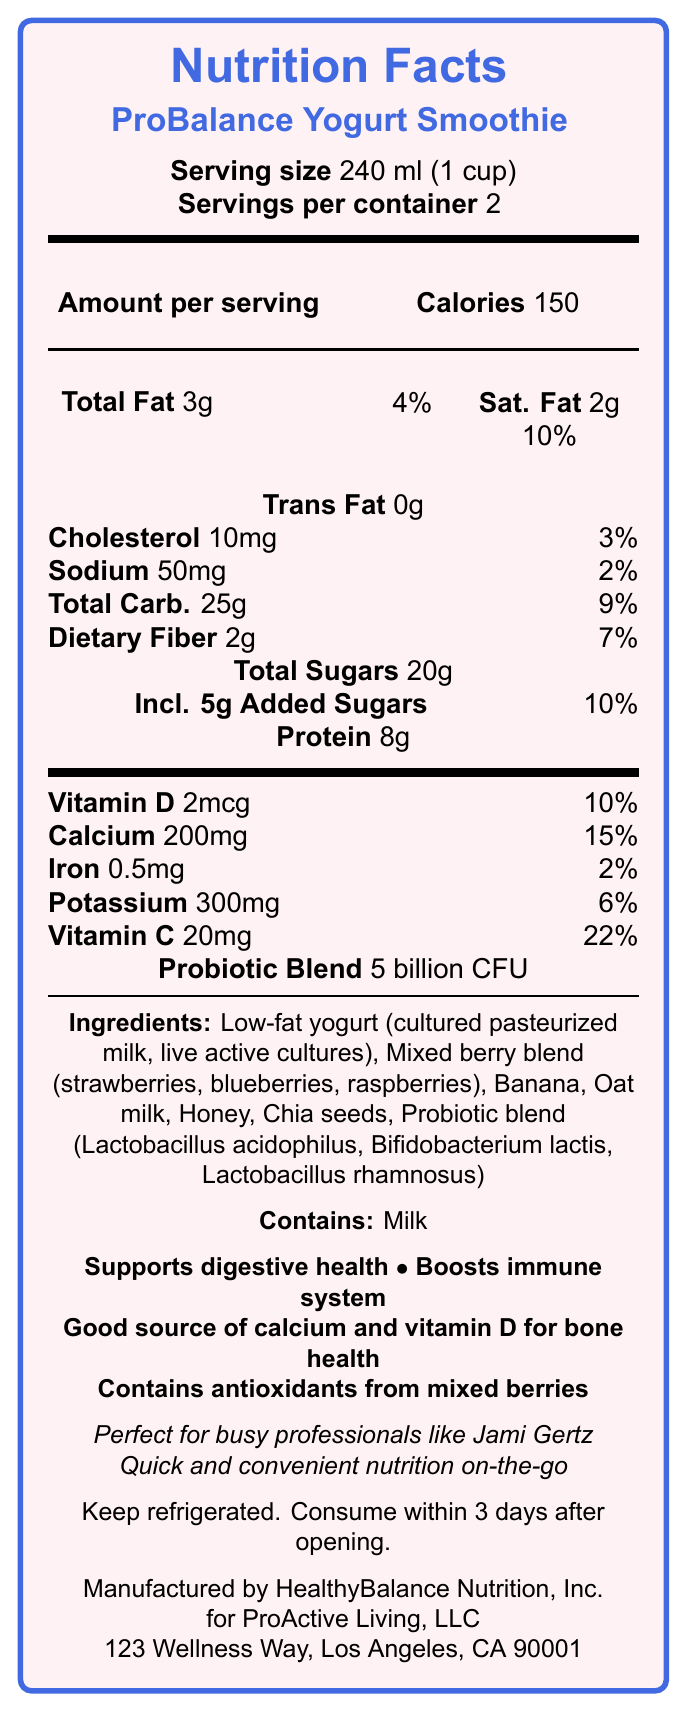How many calories are there per serving of the ProBalance Yogurt Smoothie? The document states that the calories per serving are 150.
Answer: 150 How many servings are in one container of the ProBalance Yogurt Smoothie? The document lists "Servings per container" as 2.
Answer: 2 What is the amount of total fat in one serving of the ProBalance Yogurt Smoothie? The document states that the total fat per serving is 3g.
Answer: 3g How much protein does one serving of the ProBalance Yogurt Smoothie contain? The document states that there are 8g of protein per serving.
Answer: 8g What are the ingredients listed in the ProBalance Yogurt Smoothie? The ingredients listed in the document are: Low-fat yogurt (cultured pasteurized milk, live active cultures), Mixed berry blend (strawberries, blueberries, raspberries), Banana, Oat milk, Honey, Chia seeds, Probiotic blend (Lactobacillus acidophilus, Bifidobacterium lactis, Lactobacillus rhamnosus).
Answer: Low-fat yogurt, Mixed berry blend, Banana, Oat milk, Honey, Chia seeds, Probiotic blend What is the daily value percentage of calcium in one serving of the ProBalance Yogurt Smoothie? The document indicates that the daily value percentage of calcium per serving is 15%.
Answer: 15% Which of the following health claims is associated with the ProBalance Yogurt Smoothie? A. Reduces cholesterol B. Supports digestive health C. Increases muscle mass The document states one of the health claims of the ProBalance Yogurt Smoothie is to "Supports digestive health".
Answer: B. Supports digestive health How much added sugar is in one serving of the ProBalance Yogurt Smoothie? A. 2g B. 5g C. 10g D. 15g The document states that there are 5g of "Added Sugars" per serving.
Answer: B. 5g Does the ProBalance Yogurt Smoothie contain any trans fat? The document states "Trans Fat 0g", which means there is no trans fat in the smoothie.
Answer: No Summarize the key points of the ProBalance Yogurt Smoothie nutrition facts label. This summary captures the main nutritional content, health benefits, and convenience of the ProBalance Yogurt Smoothie as presented in the document.
Answer: The ProBalance Yogurt Smoothie is a nutritious beverage containing 150 calories per serving, with 3g of total fat, 8g of protein, and 20g of total sugars, including 5g of added sugars. It provides 15% daily value of calcium and contains a probiotic blend of 5 billion CFU. The ingredients include low-fat yogurt, mixed berry blend, banana, oat milk, honey, chia seeds, and various probiotics. Health claims include supporting digestive health, boosting the immune system, and providing good sources of calcium and vitamin D. The smoothie is designed for busy professionals and offers quick and convenient nutrition on-the-go. What is the address of the manufacturer of the ProBalance Yogurt Smoothie? The document lists the distribution address as "123 Wellness Way, Los Angeles, CA 90001".
Answer: 123 Wellness Way, Los Angeles, CA 90001 What are the purported lifestyle benefits of the ProBalance Yogurt Smoothie for busy professionals like Jami Gertz? The document lists the lifestyle benefits as "Perfect for busy professionals like Jami Gertz," and includes quick and convenient nutrition on-the-go, maintaining energy levels, and supporting overall well-being during demanding schedules.
Answer: Quick and convenient nutrition on-the-go, Helps maintain energy levels throughout hectic days, Supports overall well-being during demanding schedules What is the recommended storage instruction for the ProBalance Yogurt Smoothie? The document instructs to keep the product refrigerated and consume within 3 days after opening.
Answer: Keep refrigerated. Consume within 3 days after opening. Who is the ProBalance Yogurt Smoothie manufactured by? The document states it is manufactured by HealthyBalance Nutrition, Inc.
Answer: HealthyBalance Nutrition, Inc. What is the amount of vitamin C in one serving of the ProBalance Yogurt Smoothie? The document lists the vitamin C amount as 20mg per serving.
Answer: 20mg Where is the probiotic blend used in the ProBalance Yogurt Smoothie manufactured? The document does not provide information about where the probiotic blend is manufactured.
Answer: Cannot be determined 